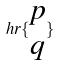<formula> <loc_0><loc_0><loc_500><loc_500>h r \{ \begin{matrix} p \\ q \end{matrix} \}</formula> 